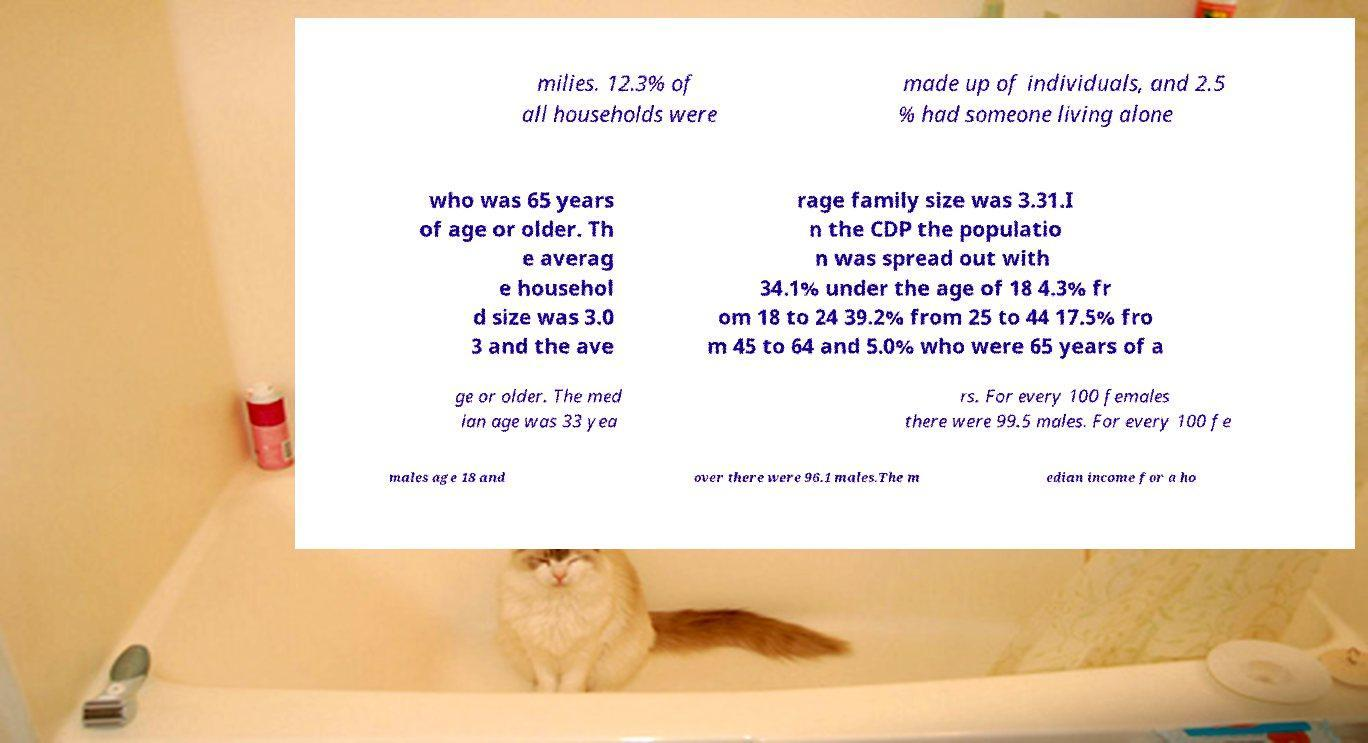For documentation purposes, I need the text within this image transcribed. Could you provide that? milies. 12.3% of all households were made up of individuals, and 2.5 % had someone living alone who was 65 years of age or older. Th e averag e househol d size was 3.0 3 and the ave rage family size was 3.31.I n the CDP the populatio n was spread out with 34.1% under the age of 18 4.3% fr om 18 to 24 39.2% from 25 to 44 17.5% fro m 45 to 64 and 5.0% who were 65 years of a ge or older. The med ian age was 33 yea rs. For every 100 females there were 99.5 males. For every 100 fe males age 18 and over there were 96.1 males.The m edian income for a ho 